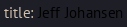Convert code to text. <code><loc_0><loc_0><loc_500><loc_500><_YAML_>title: Jeff Johansen
</code> 